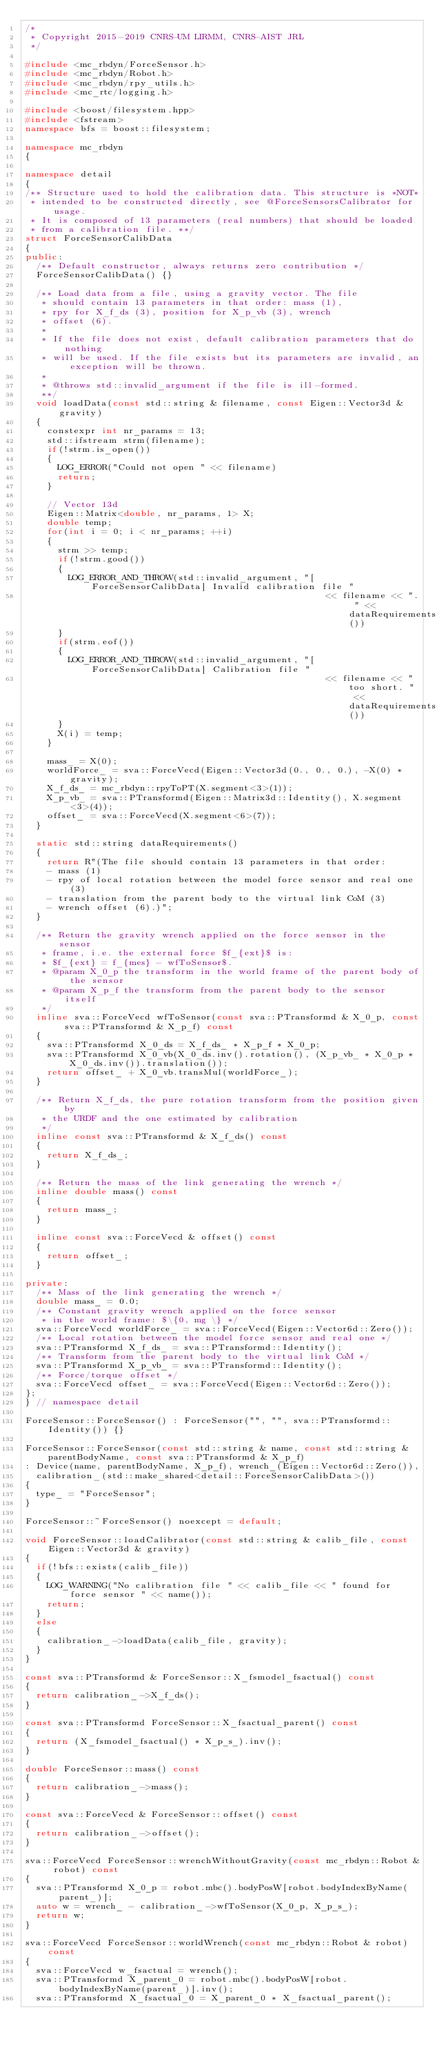<code> <loc_0><loc_0><loc_500><loc_500><_C++_>/*
 * Copyright 2015-2019 CNRS-UM LIRMM, CNRS-AIST JRL
 */

#include <mc_rbdyn/ForceSensor.h>
#include <mc_rbdyn/Robot.h>
#include <mc_rbdyn/rpy_utils.h>
#include <mc_rtc/logging.h>

#include <boost/filesystem.hpp>
#include <fstream>
namespace bfs = boost::filesystem;

namespace mc_rbdyn
{

namespace detail
{
/** Structure used to hold the calibration data. This structure is *NOT*
 * intended to be constructed directly, see @ForceSensorsCalibrator for usage.
 * It is composed of 13 parameters (real numbers) that should be loaded
 * from a calibration file. **/
struct ForceSensorCalibData
{
public:
  /** Default constructor, always returns zero contribution */
  ForceSensorCalibData() {}

  /** Load data from a file, using a gravity vector. The file
   * should contain 13 parameters in that order: mass (1),
   * rpy for X_f_ds (3), position for X_p_vb (3), wrench
   * offset (6).
   *
   * If the file does not exist, default calibration parameters that do nothing
   * will be used. If the file exists but its parameters are invalid, an exception will be thrown.
   *
   * @throws std::invalid_argument if the file is ill-formed.
   **/
  void loadData(const std::string & filename, const Eigen::Vector3d & gravity)
  {
    constexpr int nr_params = 13;
    std::ifstream strm(filename);
    if(!strm.is_open())
    {
      LOG_ERROR("Could not open " << filename)
      return;
    }

    // Vector 13d
    Eigen::Matrix<double, nr_params, 1> X;
    double temp;
    for(int i = 0; i < nr_params; ++i)
    {
      strm >> temp;
      if(!strm.good())
      {
        LOG_ERROR_AND_THROW(std::invalid_argument, "[ForceSensorCalibData] Invalid calibration file "
                                                       << filename << ". " << dataRequirements())
      }
      if(strm.eof())
      {
        LOG_ERROR_AND_THROW(std::invalid_argument, "[ForceSensorCalibData] Calibration file "
                                                       << filename << " too short. " << dataRequirements())
      }
      X(i) = temp;
    }

    mass_ = X(0);
    worldForce_ = sva::ForceVecd(Eigen::Vector3d(0., 0., 0.), -X(0) * gravity);
    X_f_ds_ = mc_rbdyn::rpyToPT(X.segment<3>(1));
    X_p_vb_ = sva::PTransformd(Eigen::Matrix3d::Identity(), X.segment<3>(4));
    offset_ = sva::ForceVecd(X.segment<6>(7));
  }

  static std::string dataRequirements()
  {
    return R"(The file should contain 13 parameters in that order:
    - mass (1)
    - rpy of local rotation between the model force sensor and real one (3)
    - translation from the parent body to the virtual link CoM (3)
    - wrench offset (6).)";
  }

  /** Return the gravity wrench applied on the force sensor in the sensor
   * frame, i.e. the external force $f_{ext}$ is:
   * $f_{ext} = f_{mes} - wfToSensor$.
   * @param X_0_p the transform in the world frame of the parent body of the sensor
   * @param X_p_f the transform from the parent body to the sensor itself
   */
  inline sva::ForceVecd wfToSensor(const sva::PTransformd & X_0_p, const sva::PTransformd & X_p_f) const
  {
    sva::PTransformd X_0_ds = X_f_ds_ * X_p_f * X_0_p;
    sva::PTransformd X_0_vb(X_0_ds.inv().rotation(), (X_p_vb_ * X_0_p * X_0_ds.inv()).translation());
    return offset_ + X_0_vb.transMul(worldForce_);
  }

  /** Return X_f_ds, the pure rotation transform from the position given by
   * the URDF and the one estimated by calibration
   */
  inline const sva::PTransformd & X_f_ds() const
  {
    return X_f_ds_;
  }

  /** Return the mass of the link generating the wrench */
  inline double mass() const
  {
    return mass_;
  }

  inline const sva::ForceVecd & offset() const
  {
    return offset_;
  }

private:
  /** Mass of the link generating the wrench */
  double mass_ = 0.0;
  /** Constant gravity wrench applied on the force sensor
   * in the world frame: $\{0, mg \} */
  sva::ForceVecd worldForce_ = sva::ForceVecd(Eigen::Vector6d::Zero());
  /** Local rotation between the model force sensor and real one */
  sva::PTransformd X_f_ds_ = sva::PTransformd::Identity();
  /** Transform from the parent body to the virtual link CoM */
  sva::PTransformd X_p_vb_ = sva::PTransformd::Identity();
  /** Force/torque offset */
  sva::ForceVecd offset_ = sva::ForceVecd(Eigen::Vector6d::Zero());
};
} // namespace detail

ForceSensor::ForceSensor() : ForceSensor("", "", sva::PTransformd::Identity()) {}

ForceSensor::ForceSensor(const std::string & name, const std::string & parentBodyName, const sva::PTransformd & X_p_f)
: Device(name, parentBodyName, X_p_f), wrench_(Eigen::Vector6d::Zero()),
  calibration_(std::make_shared<detail::ForceSensorCalibData>())
{
  type_ = "ForceSensor";
}

ForceSensor::~ForceSensor() noexcept = default;

void ForceSensor::loadCalibrator(const std::string & calib_file, const Eigen::Vector3d & gravity)
{
  if(!bfs::exists(calib_file))
  {
    LOG_WARNING("No calibration file " << calib_file << " found for force sensor " << name());
    return;
  }
  else
  {
    calibration_->loadData(calib_file, gravity);
  }
}

const sva::PTransformd & ForceSensor::X_fsmodel_fsactual() const
{
  return calibration_->X_f_ds();
}

const sva::PTransformd ForceSensor::X_fsactual_parent() const
{
  return (X_fsmodel_fsactual() * X_p_s_).inv();
}

double ForceSensor::mass() const
{
  return calibration_->mass();
}

const sva::ForceVecd & ForceSensor::offset() const
{
  return calibration_->offset();
}

sva::ForceVecd ForceSensor::wrenchWithoutGravity(const mc_rbdyn::Robot & robot) const
{
  sva::PTransformd X_0_p = robot.mbc().bodyPosW[robot.bodyIndexByName(parent_)];
  auto w = wrench_ - calibration_->wfToSensor(X_0_p, X_p_s_);
  return w;
}

sva::ForceVecd ForceSensor::worldWrench(const mc_rbdyn::Robot & robot) const
{
  sva::ForceVecd w_fsactual = wrench();
  sva::PTransformd X_parent_0 = robot.mbc().bodyPosW[robot.bodyIndexByName(parent_)].inv();
  sva::PTransformd X_fsactual_0 = X_parent_0 * X_fsactual_parent();</code> 